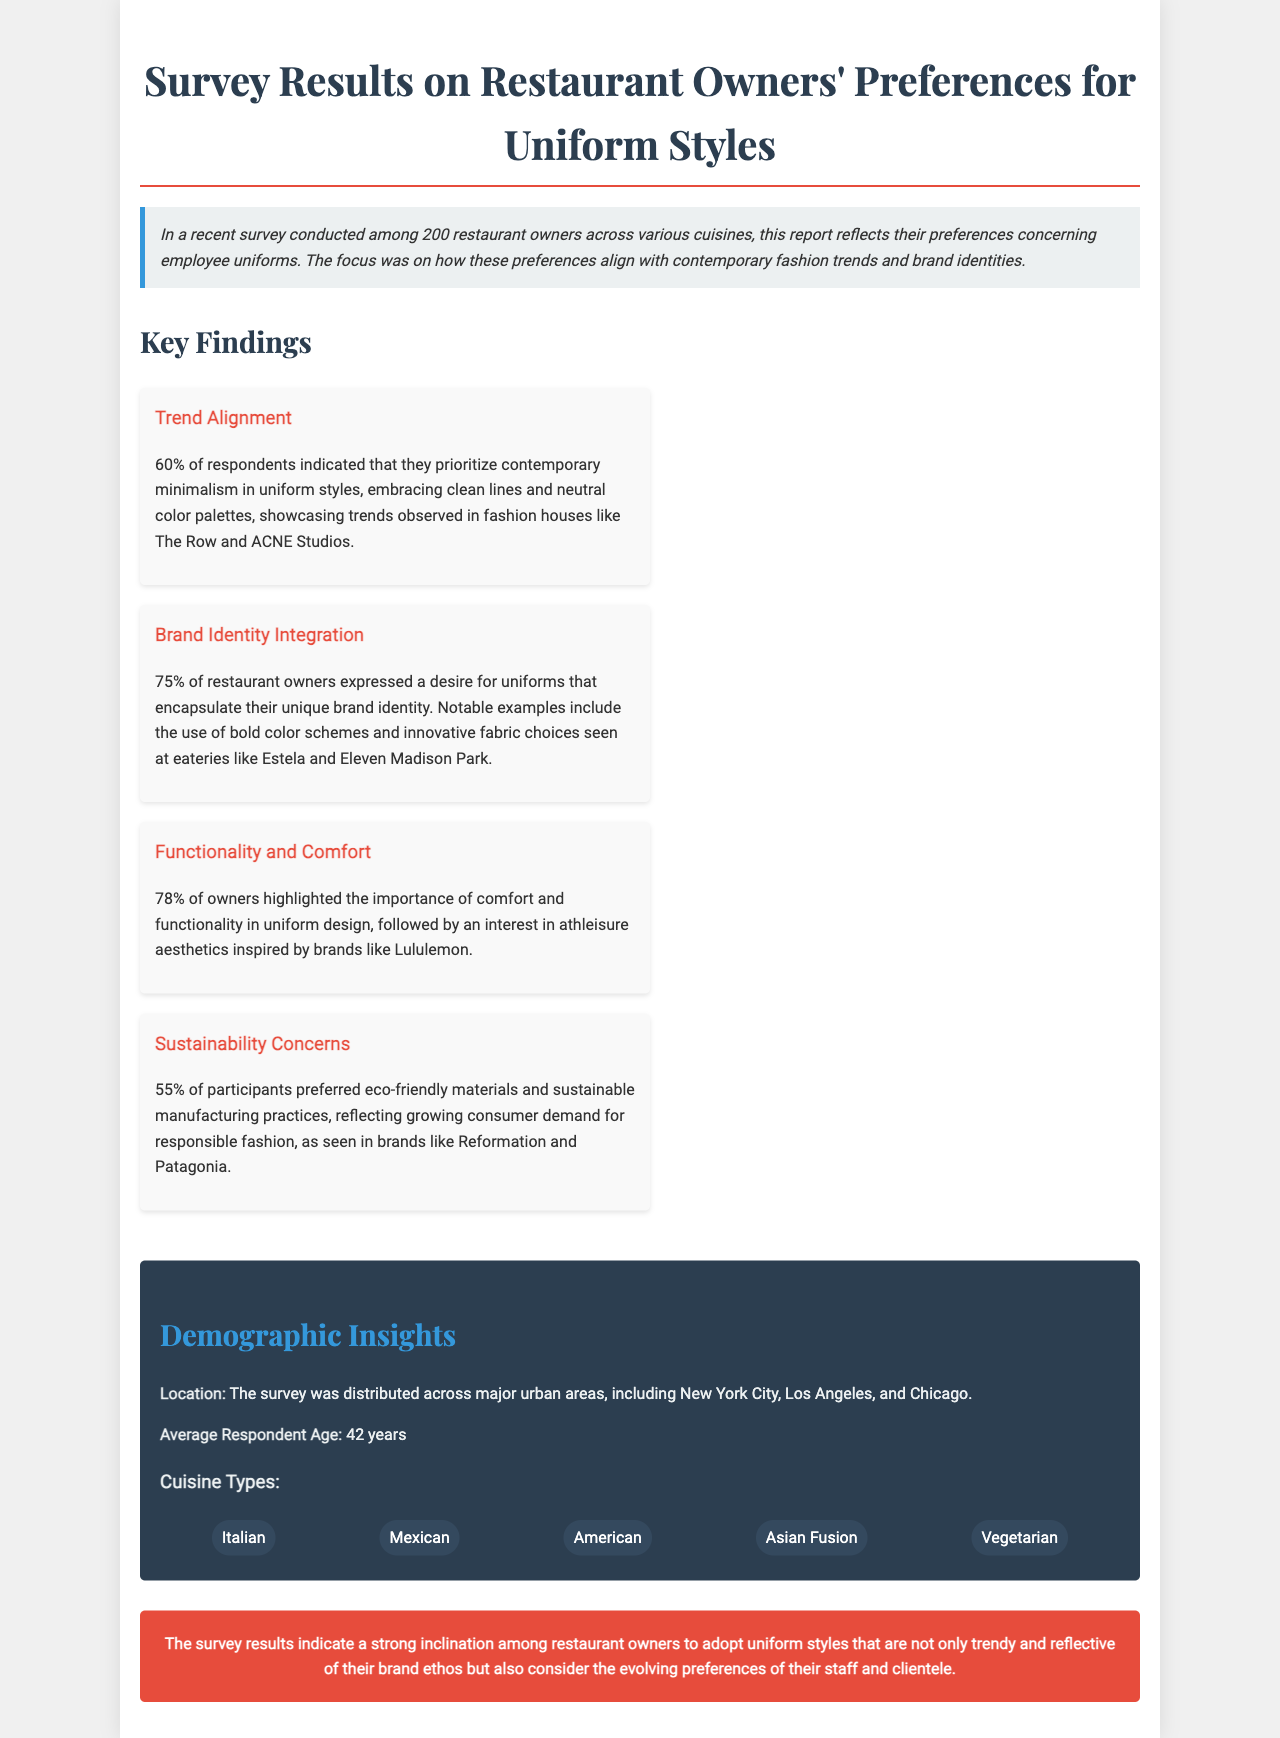What percentage of restaurant owners prioritize contemporary minimalism? The percentage of restaurant owners who prioritize contemporary minimalism is explicitly stated in the report.
Answer: 60% What percentage of owners expressed a desire for uniforms that encapsulate their unique brand identity? This figure is noted in the section about brand identity integration.
Answer: 75% Which cities were included in the demographic insights for the survey? The document explicitly lists major urban areas where the survey was distributed.
Answer: New York City, Los Angeles, Chicago What is the average age of respondents? The average age of respondents is mentioned in the demographics section.
Answer: 42 years What percentage of interviewees highlighted comfort and functionality as important in uniform design? This percentage is highlighted under the functionality and comfort finding.
Answer: 78% What is the sustainability preference percentage indicated by survey participants? The document mentions this percentage in the sustainability concerns section.
Answer: 55% What cuisine type is listed first in the survey demographics? The cuisine type order is provided in the findings for cuisine types.
Answer: Italian How does the survey reflect contemporary fashion trends? The survey's alignment with contemporary fashion trends is summarized in the key findings section.
Answer: Trend Alignment What aesthetic inspired the interest in comfort among restaurant owners? The document specifies the aesthetic influencing preferences outlined in the findings.
Answer: Athleisure 